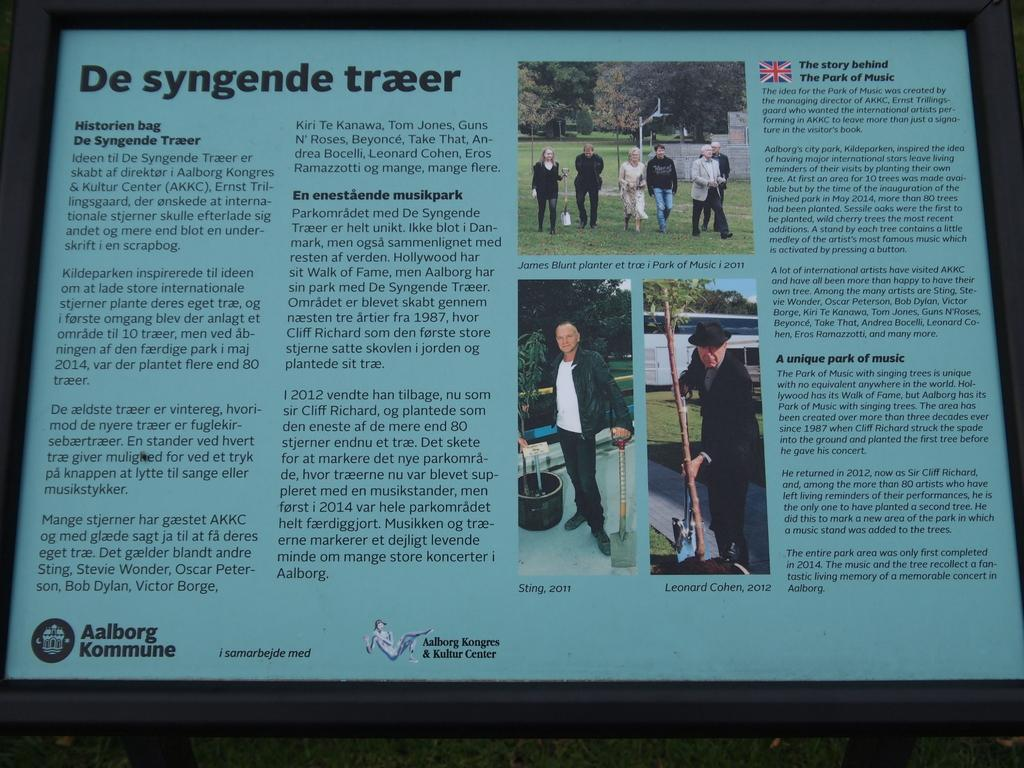Provide a one-sentence caption for the provided image. An article released Aalborg Kongres & Kultur Center has a British article called "The Story behind The Park of Music". 